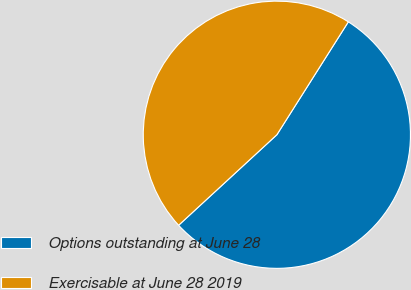Convert chart. <chart><loc_0><loc_0><loc_500><loc_500><pie_chart><fcel>Options outstanding at June 28<fcel>Exercisable at June 28 2019<nl><fcel>54.17%<fcel>45.83%<nl></chart> 